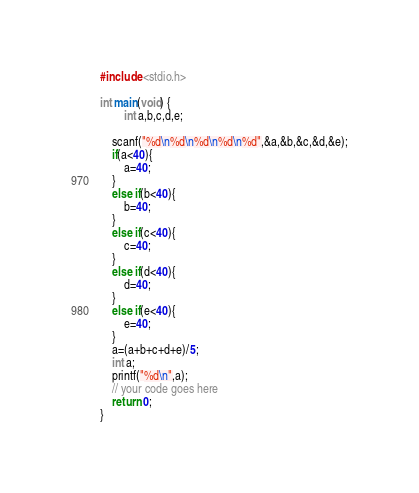Convert code to text. <code><loc_0><loc_0><loc_500><loc_500><_C_>#include <stdio.h>

int main(void) {
		int a,b,c,d,e;
	
	scanf("%d\n%d\n%d\n%d\n%d",&a,&b,&c,&d,&e);
	if(a<40){
		a=40;
	}
	else if(b<40){
		b=40;
	}
	else if(c<40){
		c=40;
	}
	else if(d<40){
		d=40;
	}
	else if(e<40){
		e=40;
	}
	a=(a+b+c+d+e)/5;
	int a;
	printf("%d\n",a);
	// your code goes here
	return 0;
}</code> 